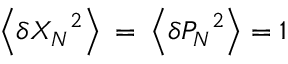<formula> <loc_0><loc_0><loc_500><loc_500>\left \langle \delta { { X } _ { N } } ^ { 2 } \right \rangle = \left \langle \delta { { P } _ { N } } ^ { 2 } \right \rangle = 1</formula> 